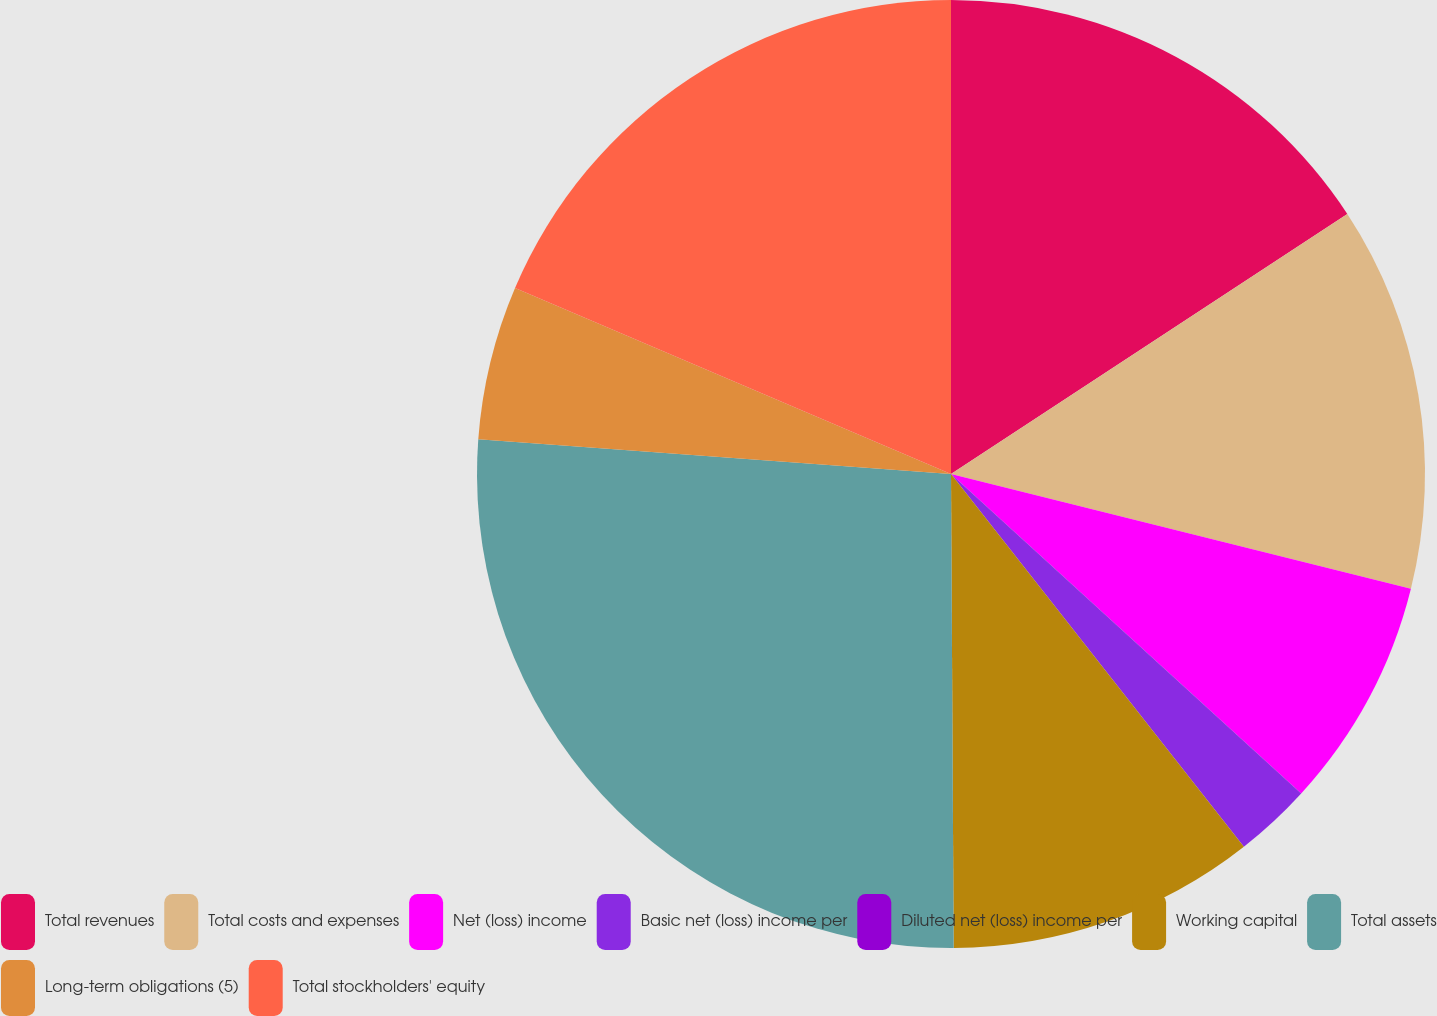<chart> <loc_0><loc_0><loc_500><loc_500><pie_chart><fcel>Total revenues<fcel>Total costs and expenses<fcel>Net (loss) income<fcel>Basic net (loss) income per<fcel>Diluted net (loss) income per<fcel>Working capital<fcel>Total assets<fcel>Long-term obligations (5)<fcel>Total stockholders' equity<nl><fcel>15.76%<fcel>13.13%<fcel>7.88%<fcel>2.63%<fcel>0.0%<fcel>10.51%<fcel>26.26%<fcel>5.25%<fcel>18.58%<nl></chart> 